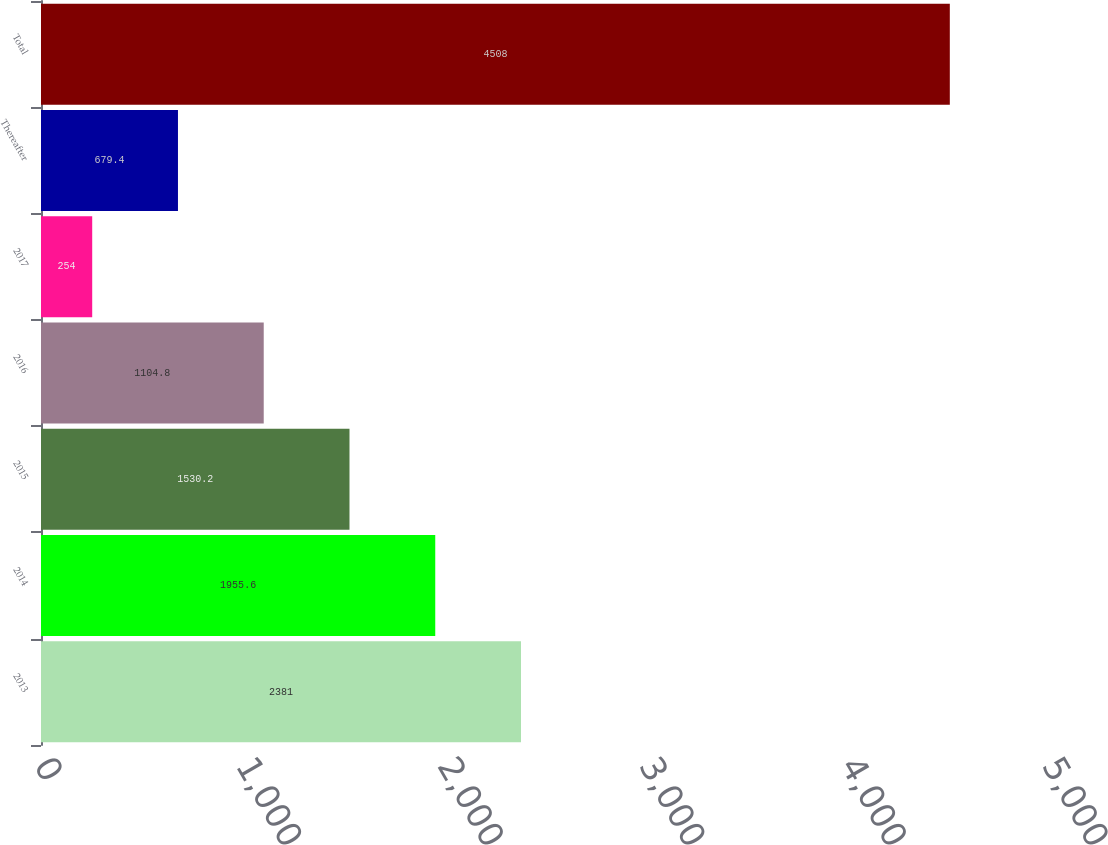Convert chart to OTSL. <chart><loc_0><loc_0><loc_500><loc_500><bar_chart><fcel>2013<fcel>2014<fcel>2015<fcel>2016<fcel>2017<fcel>Thereafter<fcel>Total<nl><fcel>2381<fcel>1955.6<fcel>1530.2<fcel>1104.8<fcel>254<fcel>679.4<fcel>4508<nl></chart> 